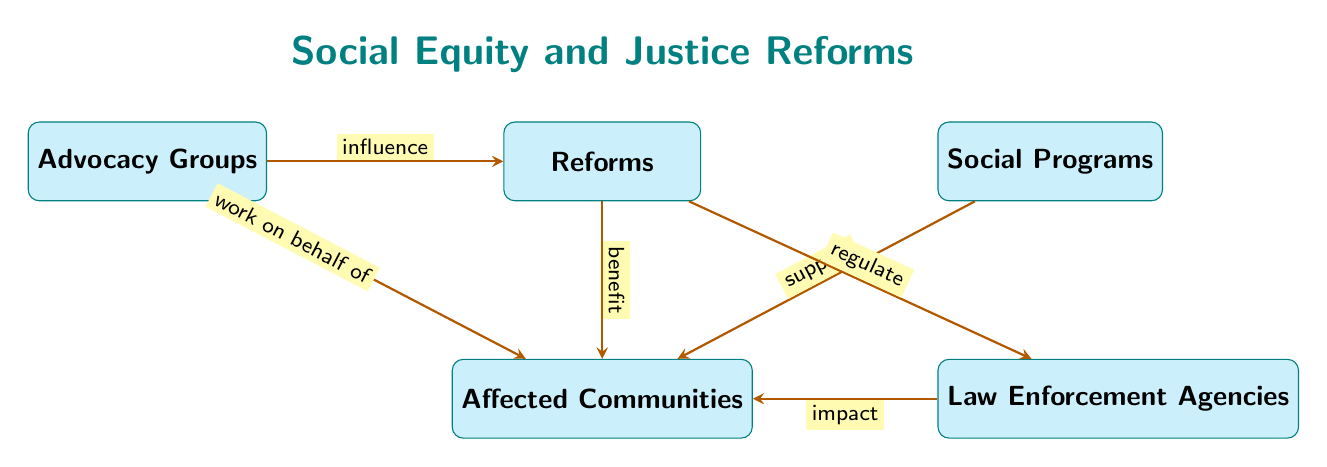What are the entities represented in the diagram? The diagram contains five entities: Reforms, Affected Communities, Social Programs, Law Enforcement Agencies, and Advocacy Groups.
Answer: Reforms, Affected Communities, Social Programs, Law Enforcement Agencies, Advocacy Groups How many relationships are shown in the diagram? The diagram illustrates six relationships between entities.
Answer: 6 What does the arrow between Reforms and Affected Communities indicate? The arrow denotes that Reforms benefit Affected Communities, showing a positive impact flowing from Reforms to those Communities.
Answer: benefit Which entity influences the creation of Reforms? The Advocacy Groups influence the creation of Reforms, as indicated by the arrow pointing from Advocacy Groups to Reforms.
Answer: Advocacy Groups What is the relationship between Law Enforcement Agencies and Affected Communities? The relationship indicates that Law Enforcement Agencies have impacts on Affected Communities, conveying an effect from the Agencies to the Communities.
Answer: impact How do Social Programs relate to Affected Communities? Social Programs support Affected Communities, as illustrated by the arrow directing from Social Programs to Affected Communities.
Answer: support If Advocacy Groups work on behalf of Affected Communities, what does that suggest about their role? This suggests that Advocacy Groups act to represent and advocate for the interests and needs of Affected Communities, indicating a protective and supportive role.
Answer: work on behalf of What two entities are directly linked to Reforms with a relationship? The entities directly linked to Reforms with a relationship are Affected Communities and Law Enforcement Agencies.
Answer: Affected Communities, Law Enforcement Agencies Which relationship shows the flow of support towards Affected Communities? The relationships that showcase support flowing towards Affected Communities are from Reforms and Social Programs.
Answer: Reforms, Social Programs 